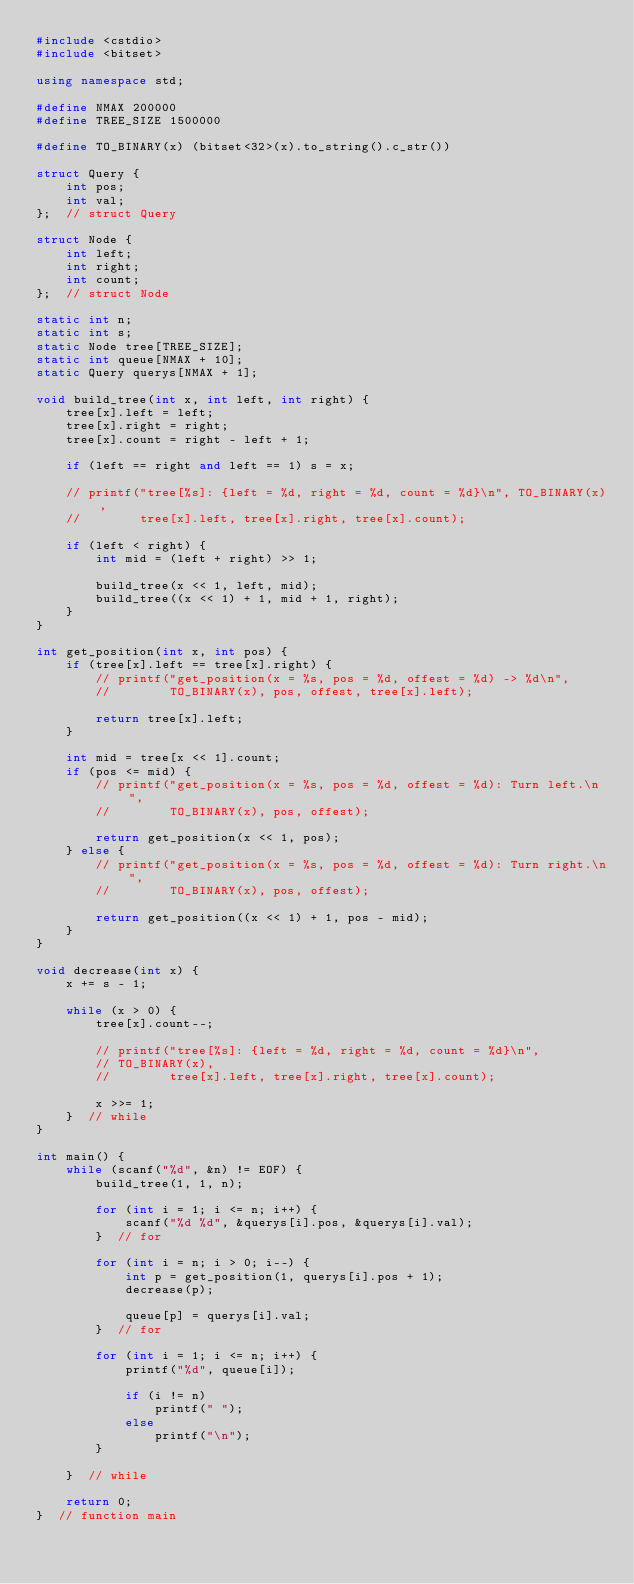Convert code to text. <code><loc_0><loc_0><loc_500><loc_500><_C++_>#include <cstdio>
#include <bitset>

using namespace std;

#define NMAX 200000
#define TREE_SIZE 1500000

#define TO_BINARY(x) (bitset<32>(x).to_string().c_str())

struct Query {
    int pos;
    int val;
};  // struct Query

struct Node {
    int left;
    int right;
    int count;
};  // struct Node

static int n;
static int s;
static Node tree[TREE_SIZE];
static int queue[NMAX + 10];
static Query querys[NMAX + 1];

void build_tree(int x, int left, int right) {
    tree[x].left = left;
    tree[x].right = right;
    tree[x].count = right - left + 1;

    if (left == right and left == 1) s = x;

    // printf("tree[%s]: {left = %d, right = %d, count = %d}\n", TO_BINARY(x),
    //        tree[x].left, tree[x].right, tree[x].count);

    if (left < right) {
        int mid = (left + right) >> 1;

        build_tree(x << 1, left, mid);
        build_tree((x << 1) + 1, mid + 1, right);
    }
}

int get_position(int x, int pos) {
    if (tree[x].left == tree[x].right) {
        // printf("get_position(x = %s, pos = %d, offest = %d) -> %d\n",
        //        TO_BINARY(x), pos, offest, tree[x].left);

        return tree[x].left;
    }

    int mid = tree[x << 1].count;
    if (pos <= mid) {
        // printf("get_position(x = %s, pos = %d, offest = %d): Turn left.\n",
        //        TO_BINARY(x), pos, offest);

        return get_position(x << 1, pos);
    } else {
        // printf("get_position(x = %s, pos = %d, offest = %d): Turn right.\n",
        //        TO_BINARY(x), pos, offest);

        return get_position((x << 1) + 1, pos - mid);
    }
}

void decrease(int x) {
    x += s - 1;

    while (x > 0) {
        tree[x].count--;

        // printf("tree[%s]: {left = %d, right = %d, count = %d}\n",
        // TO_BINARY(x),
        //        tree[x].left, tree[x].right, tree[x].count);

        x >>= 1;
    }  // while
}

int main() {
    while (scanf("%d", &n) != EOF) {
        build_tree(1, 1, n);

        for (int i = 1; i <= n; i++) {
            scanf("%d %d", &querys[i].pos, &querys[i].val);
        }  // for

        for (int i = n; i > 0; i--) {
            int p = get_position(1, querys[i].pos + 1);
            decrease(p);

            queue[p] = querys[i].val;
        }  // for

        for (int i = 1; i <= n; i++) {
            printf("%d", queue[i]);

            if (i != n)
                printf(" ");
            else
                printf("\n");
        }

    }  // while

    return 0;
}  // function main
</code> 